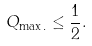<formula> <loc_0><loc_0><loc_500><loc_500>Q _ { \max . } \leq \frac { 1 } { 2 } .</formula> 